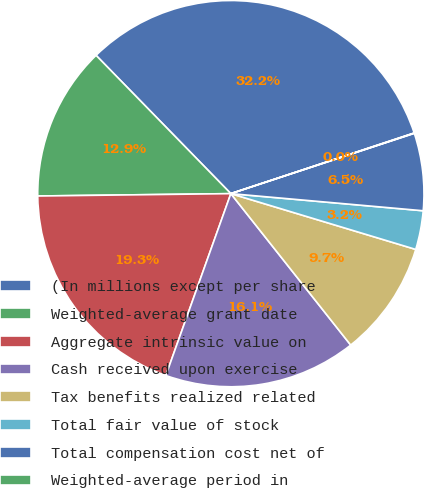Convert chart to OTSL. <chart><loc_0><loc_0><loc_500><loc_500><pie_chart><fcel>(In millions except per share<fcel>Weighted-average grant date<fcel>Aggregate intrinsic value on<fcel>Cash received upon exercise<fcel>Tax benefits realized related<fcel>Total fair value of stock<fcel>Total compensation cost net of<fcel>Weighted-average period in<nl><fcel>32.21%<fcel>12.9%<fcel>19.34%<fcel>16.12%<fcel>9.68%<fcel>3.25%<fcel>6.47%<fcel>0.03%<nl></chart> 